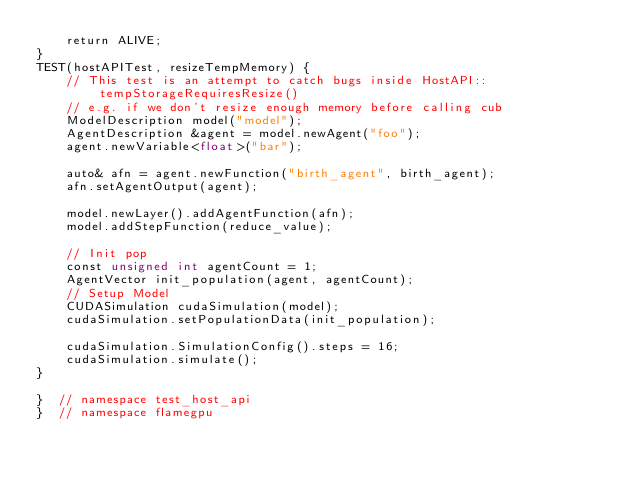<code> <loc_0><loc_0><loc_500><loc_500><_Cuda_>    return ALIVE;
}
TEST(hostAPITest, resizeTempMemory) {
    // This test is an attempt to catch bugs inside HostAPI::tempStorageRequiresResize()
    // e.g. if we don't resize enough memory before calling cub
    ModelDescription model("model");
    AgentDescription &agent = model.newAgent("foo");
    agent.newVariable<float>("bar");

    auto& afn = agent.newFunction("birth_agent", birth_agent);
    afn.setAgentOutput(agent);

    model.newLayer().addAgentFunction(afn);
    model.addStepFunction(reduce_value);

    // Init pop
    const unsigned int agentCount = 1;
    AgentVector init_population(agent, agentCount);
    // Setup Model
    CUDASimulation cudaSimulation(model);
    cudaSimulation.setPopulationData(init_population);

    cudaSimulation.SimulationConfig().steps = 16;
    cudaSimulation.simulate();
}

}  // namespace test_host_api
}  // namespace flamegpu
</code> 